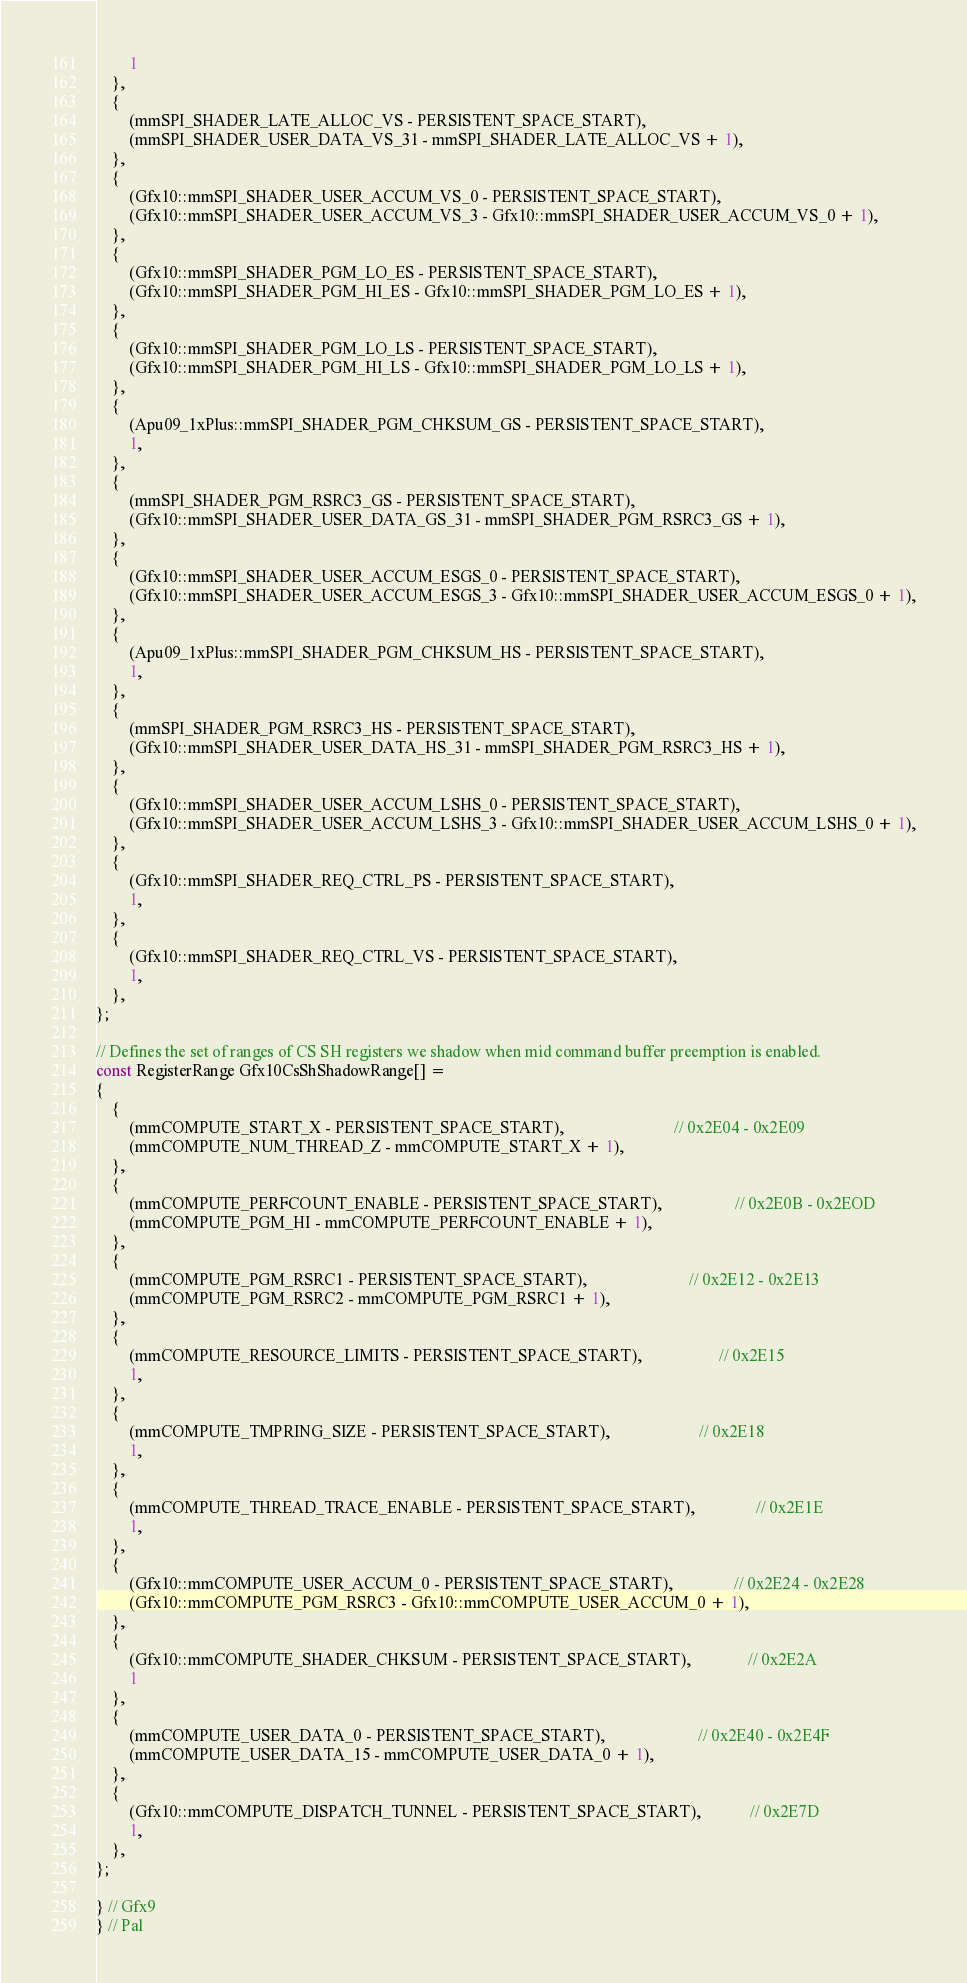Convert code to text. <code><loc_0><loc_0><loc_500><loc_500><_C_>        1
    },
    {
        (mmSPI_SHADER_LATE_ALLOC_VS - PERSISTENT_SPACE_START),
        (mmSPI_SHADER_USER_DATA_VS_31 - mmSPI_SHADER_LATE_ALLOC_VS + 1),
    },
    {
        (Gfx10::mmSPI_SHADER_USER_ACCUM_VS_0 - PERSISTENT_SPACE_START),
        (Gfx10::mmSPI_SHADER_USER_ACCUM_VS_3 - Gfx10::mmSPI_SHADER_USER_ACCUM_VS_0 + 1),
    },
    {
        (Gfx10::mmSPI_SHADER_PGM_LO_ES - PERSISTENT_SPACE_START),
        (Gfx10::mmSPI_SHADER_PGM_HI_ES - Gfx10::mmSPI_SHADER_PGM_LO_ES + 1),
    },
    {
        (Gfx10::mmSPI_SHADER_PGM_LO_LS - PERSISTENT_SPACE_START),
        (Gfx10::mmSPI_SHADER_PGM_HI_LS - Gfx10::mmSPI_SHADER_PGM_LO_LS + 1),
    },
    {
        (Apu09_1xPlus::mmSPI_SHADER_PGM_CHKSUM_GS - PERSISTENT_SPACE_START),
        1,
    },
    {
        (mmSPI_SHADER_PGM_RSRC3_GS - PERSISTENT_SPACE_START),
        (Gfx10::mmSPI_SHADER_USER_DATA_GS_31 - mmSPI_SHADER_PGM_RSRC3_GS + 1),
    },
    {
        (Gfx10::mmSPI_SHADER_USER_ACCUM_ESGS_0 - PERSISTENT_SPACE_START),
        (Gfx10::mmSPI_SHADER_USER_ACCUM_ESGS_3 - Gfx10::mmSPI_SHADER_USER_ACCUM_ESGS_0 + 1),
    },
    {
        (Apu09_1xPlus::mmSPI_SHADER_PGM_CHKSUM_HS - PERSISTENT_SPACE_START),
        1,
    },
    {
        (mmSPI_SHADER_PGM_RSRC3_HS - PERSISTENT_SPACE_START),
        (Gfx10::mmSPI_SHADER_USER_DATA_HS_31 - mmSPI_SHADER_PGM_RSRC3_HS + 1),
    },
    {
        (Gfx10::mmSPI_SHADER_USER_ACCUM_LSHS_0 - PERSISTENT_SPACE_START),
        (Gfx10::mmSPI_SHADER_USER_ACCUM_LSHS_3 - Gfx10::mmSPI_SHADER_USER_ACCUM_LSHS_0 + 1),
    },
    {
        (Gfx10::mmSPI_SHADER_REQ_CTRL_PS - PERSISTENT_SPACE_START),
        1,
    },
    {
        (Gfx10::mmSPI_SHADER_REQ_CTRL_VS - PERSISTENT_SPACE_START),
        1,
    },
};

// Defines the set of ranges of CS SH registers we shadow when mid command buffer preemption is enabled.
const RegisterRange Gfx10CsShShadowRange[] =
{
    {
        (mmCOMPUTE_START_X - PERSISTENT_SPACE_START),                           // 0x2E04 - 0x2E09
        (mmCOMPUTE_NUM_THREAD_Z - mmCOMPUTE_START_X + 1),
    },
    {
        (mmCOMPUTE_PERFCOUNT_ENABLE - PERSISTENT_SPACE_START),                  // 0x2E0B - 0x2EOD
        (mmCOMPUTE_PGM_HI - mmCOMPUTE_PERFCOUNT_ENABLE + 1),
    },
    {
        (mmCOMPUTE_PGM_RSRC1 - PERSISTENT_SPACE_START),                         // 0x2E12 - 0x2E13
        (mmCOMPUTE_PGM_RSRC2 - mmCOMPUTE_PGM_RSRC1 + 1),
    },
    {
        (mmCOMPUTE_RESOURCE_LIMITS - PERSISTENT_SPACE_START),                   // 0x2E15
        1,
    },
    {
        (mmCOMPUTE_TMPRING_SIZE - PERSISTENT_SPACE_START),                      // 0x2E18
        1,
    },
    {
        (mmCOMPUTE_THREAD_TRACE_ENABLE - PERSISTENT_SPACE_START),               // 0x2E1E
        1,
    },
    {
        (Gfx10::mmCOMPUTE_USER_ACCUM_0 - PERSISTENT_SPACE_START),               // 0x2E24 - 0x2E28
        (Gfx10::mmCOMPUTE_PGM_RSRC3 - Gfx10::mmCOMPUTE_USER_ACCUM_0 + 1),
    },
    {
        (Gfx10::mmCOMPUTE_SHADER_CHKSUM - PERSISTENT_SPACE_START),              // 0x2E2A
        1
    },
    {
        (mmCOMPUTE_USER_DATA_0 - PERSISTENT_SPACE_START),                       // 0x2E40 - 0x2E4F
        (mmCOMPUTE_USER_DATA_15 - mmCOMPUTE_USER_DATA_0 + 1),
    },
    {
        (Gfx10::mmCOMPUTE_DISPATCH_TUNNEL - PERSISTENT_SPACE_START),            // 0x2E7D
        1,
    },
};

} // Gfx9
} // Pal

</code> 